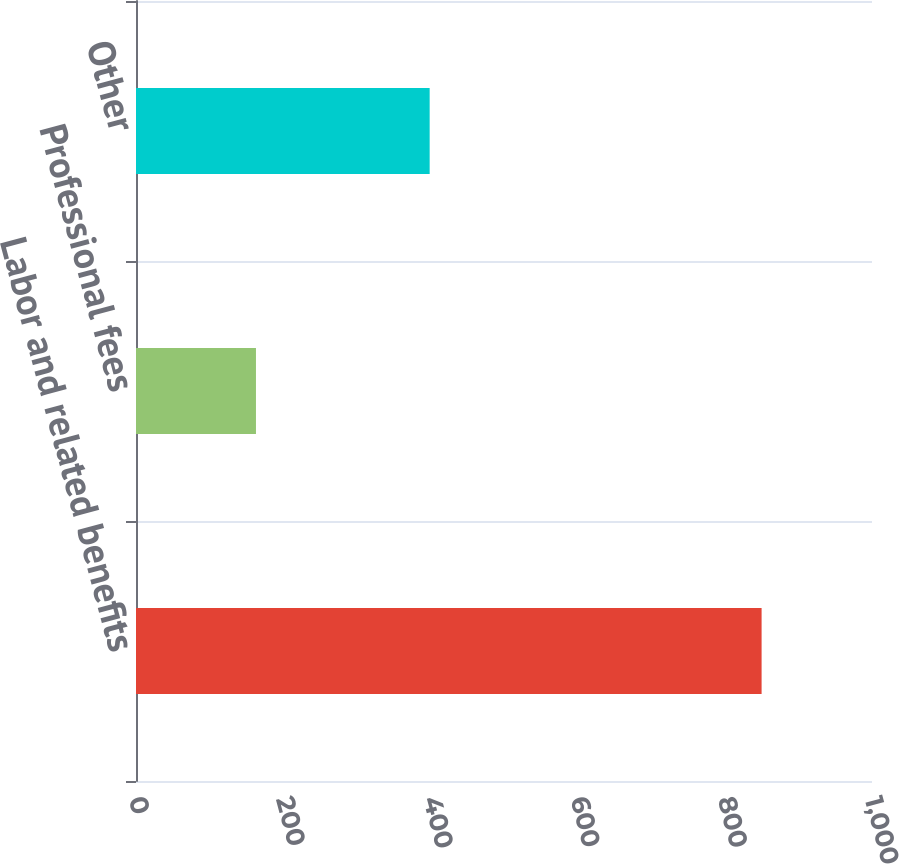<chart> <loc_0><loc_0><loc_500><loc_500><bar_chart><fcel>Labor and related benefits<fcel>Professional fees<fcel>Other<nl><fcel>850<fcel>163<fcel>399<nl></chart> 